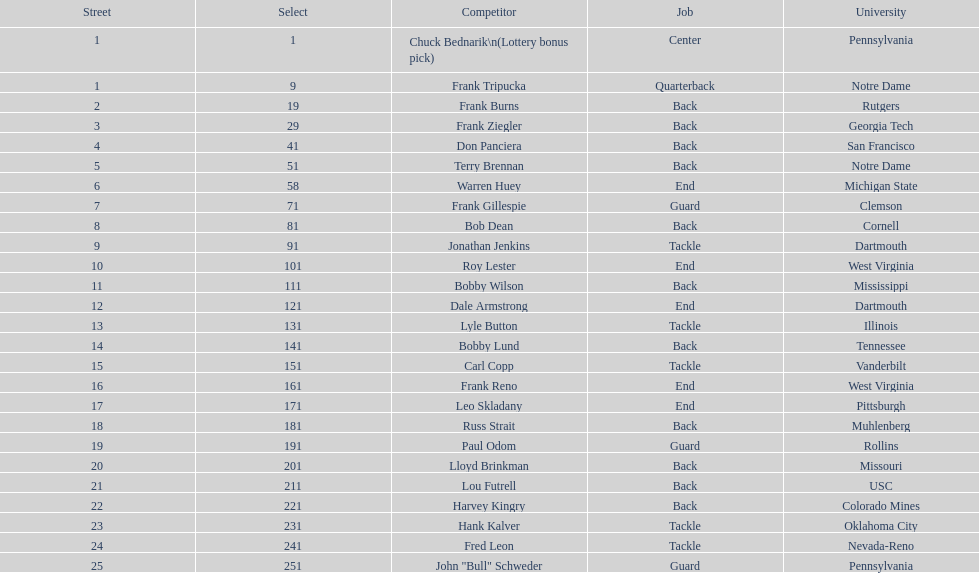Most prevalent school Pennsylvania. 